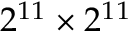Convert formula to latex. <formula><loc_0><loc_0><loc_500><loc_500>2 ^ { 1 1 } \times 2 ^ { 1 1 }</formula> 